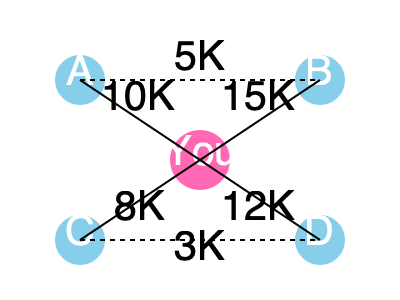Given the influencer network graph above, where nodes represent beauty influencers and edge weights represent shared followers, what is the optimal strategy to maximize the reach of a new tech-beauty product launch through influencer collaborations, and what is the total potential reach? To determine the optimal strategy and maximum reach, we'll follow these steps:

1. Analyze the network structure:
   - You (central node) are connected to four influencers: A, B, C, and D.
   - Influencers A and B are connected, as are C and D.

2. Calculate the reach for each influencer:
   - A: 10K followers
   - B: 15K followers
   - C: 8K followers
   - D: 12K followers

3. Consider the shared followers:
   - A and B share 5K followers
   - C and D share 3K followers

4. Calculate the total unique reach:
   $$(10K + 15K - 5K) + (8K + 12K - 3K) = 37K$$

5. Determine the optimal strategy:
   - Collaborate with all four influencers to maximize reach.
   - Focus on creating unique content with each influencer to minimize overlap.
   - Leverage the connections between A-B and C-D for cross-promotion.

6. Maximize engagement:
   - Tailor tech-beauty product messaging to each influencer's audience.
   - Encourage influencers to highlight the intersection of beauty and technology.

7. Utilize the network effect:
   - Create a campaign that encourages followers to share and tag friends, potentially reaching beyond the immediate network.

The optimal strategy is to collaborate with all four influencers while minimizing content overlap. This approach leverages the full network and accounts for shared followers, maximizing the unique reach to 37,000 potential customers.
Answer: Collaborate with all influencers; 37,000 potential reach 